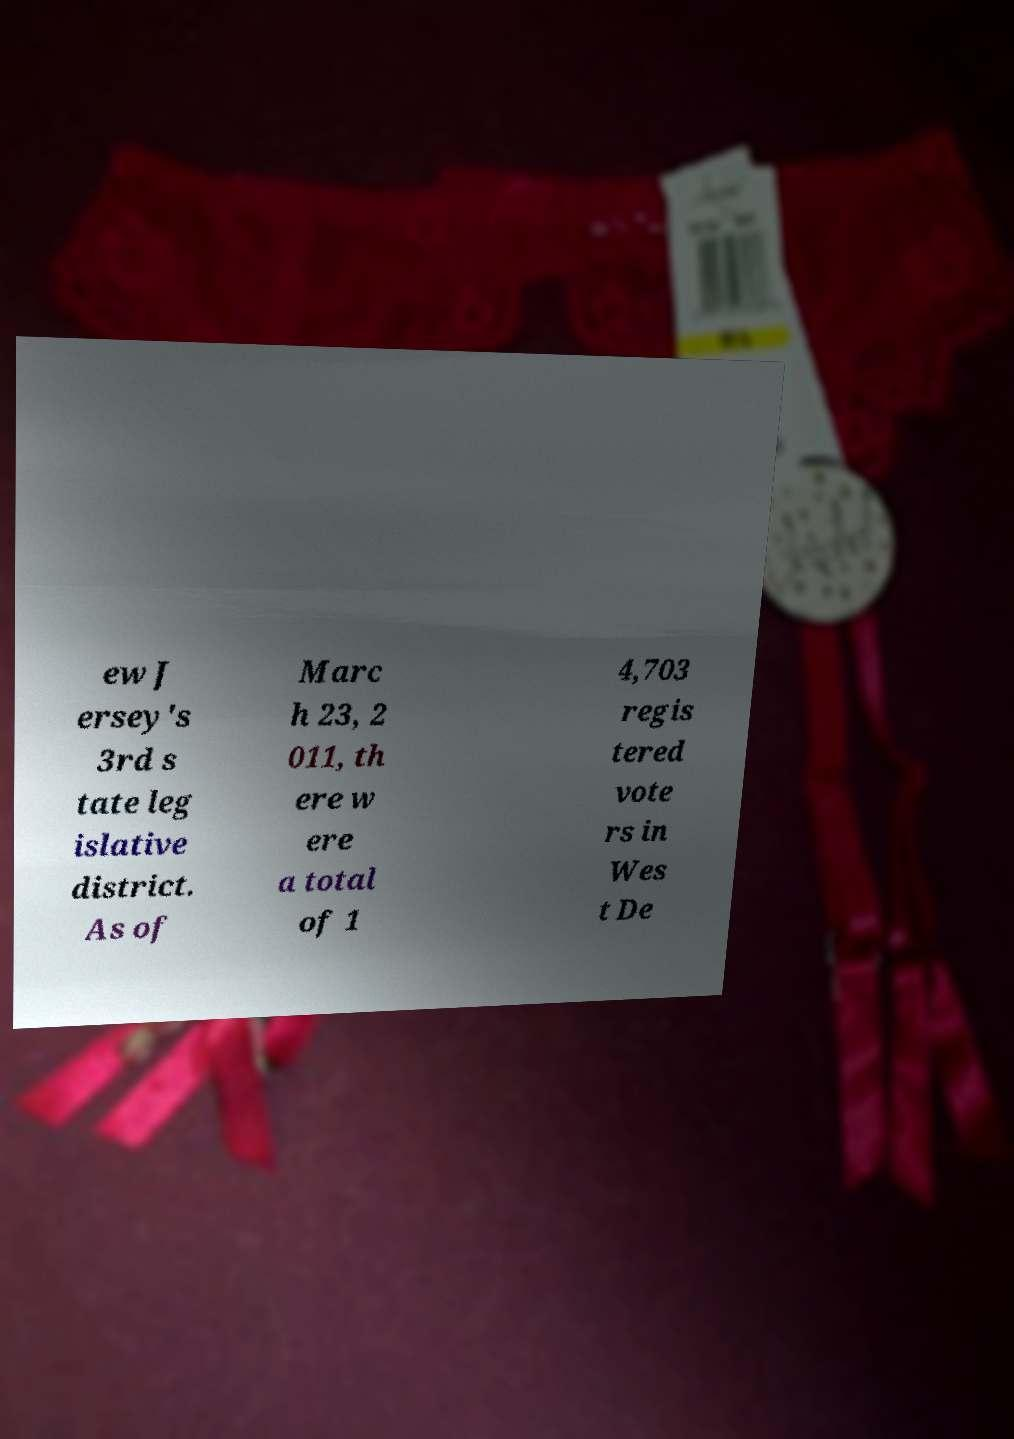Please identify and transcribe the text found in this image. ew J ersey's 3rd s tate leg islative district. As of Marc h 23, 2 011, th ere w ere a total of 1 4,703 regis tered vote rs in Wes t De 